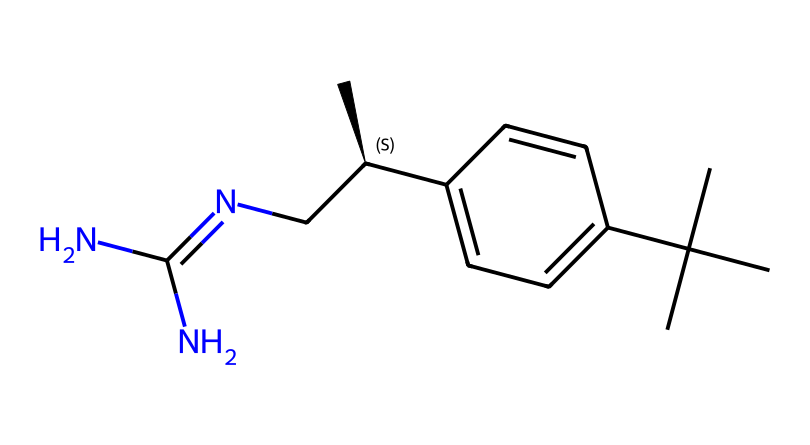which atoms are present in this chemical? The SMILES representation reveals the presence of carbon (C), nitrogen (N), and hydrogen (H) atoms. By counting each element represented in the SMILES, we identify that there are carbons in the aromatic ring and additional carbons in the branches, along with two nitrogen atoms in the structure.
Answer: carbon, nitrogen, hydrogen how many nitrogen atoms are in the molecule? The SMILES indicates two "N" letters, which represent nitrogen atoms. This allows us to confirm that there are exactly two nitrogen atoms present in the structure.
Answer: two what type of functional group is indicated by CN=C? The "C=N" portion indicates a presence of an imine functional group, as it shows a carbon double-bonded to nitrogen, thus indicating the characteristic feature of imines.
Answer: imine what is the hybridization of the nitrogen atoms? In the structure, both nitrogen atoms are bonded to carbon and a hydrogen atom (in the case of one), indicating sp2 hybridization, as they participate in a double bond and have a lone pair.
Answer: sp2 what property is likely enhanced by the bulky carbon group (CC(C)(C))? The presence of a bulky tert-butyl group (CC(C)(C)) in the structure enhances the hydrophobic character, making it effective for repelling water and enhancing its activity as a repellent.
Answer: hydrophobicity which structural feature suggests this compound may be an effective repellent? The presence of an imine group (C=N) along with numerous carbon branches suggests enhanced lipophilicity and intermolecular interactions, which can contribute to its effectiveness as a repellent.
Answer: imine group 